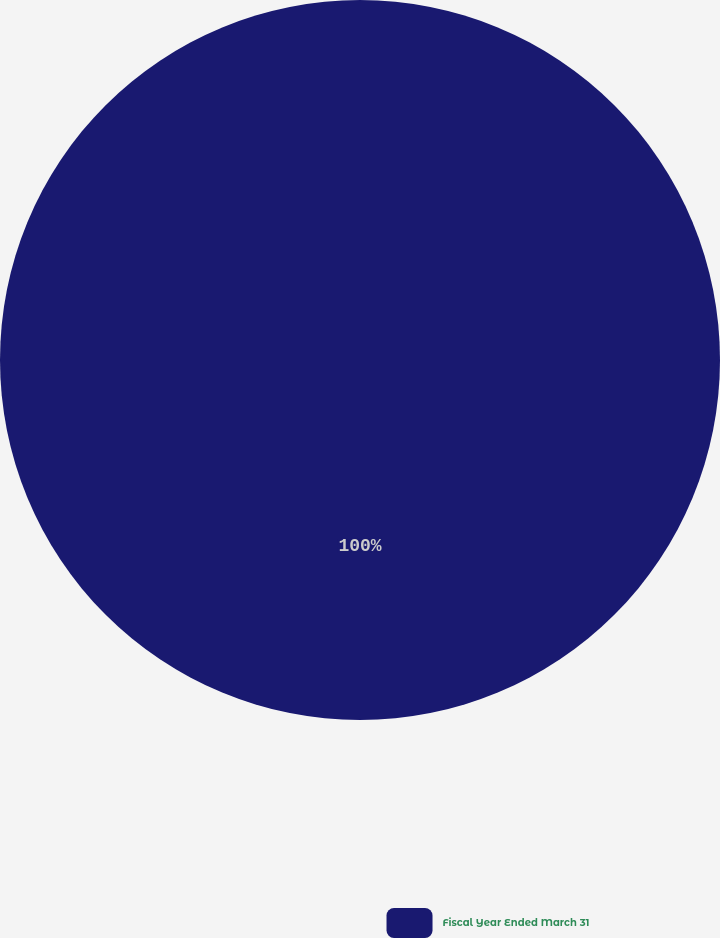<chart> <loc_0><loc_0><loc_500><loc_500><pie_chart><fcel>Fiscal Year Ended March 31<nl><fcel>100.0%<nl></chart> 